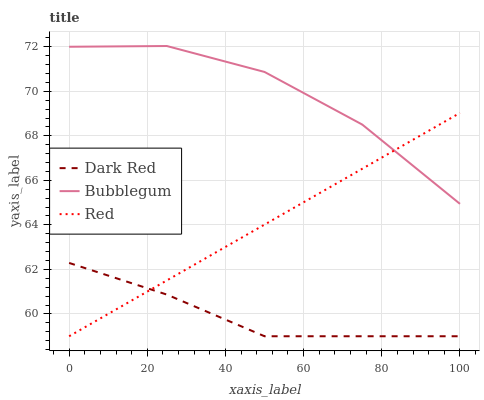Does Red have the minimum area under the curve?
Answer yes or no. No. Does Red have the maximum area under the curve?
Answer yes or no. No. Is Bubblegum the smoothest?
Answer yes or no. No. Is Red the roughest?
Answer yes or no. No. Does Bubblegum have the lowest value?
Answer yes or no. No. Does Red have the highest value?
Answer yes or no. No. Is Dark Red less than Bubblegum?
Answer yes or no. Yes. Is Bubblegum greater than Dark Red?
Answer yes or no. Yes. Does Dark Red intersect Bubblegum?
Answer yes or no. No. 